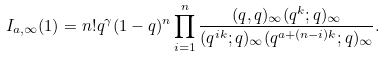Convert formula to latex. <formula><loc_0><loc_0><loc_500><loc_500>I _ { a , \infty } ( 1 ) = n ! q ^ { \gamma } ( 1 - q ) ^ { n } \prod _ { i = 1 } ^ { n } \frac { ( q , q ) _ { \infty } ( q ^ { k } ; q ) _ { \infty } } { ( q ^ { i k } ; q ) _ { \infty } ( q ^ { a + ( n - i ) k } ; q ) _ { \infty } } .</formula> 